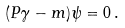Convert formula to latex. <formula><loc_0><loc_0><loc_500><loc_500>( P \gamma - m ) \psi = 0 \, .</formula> 